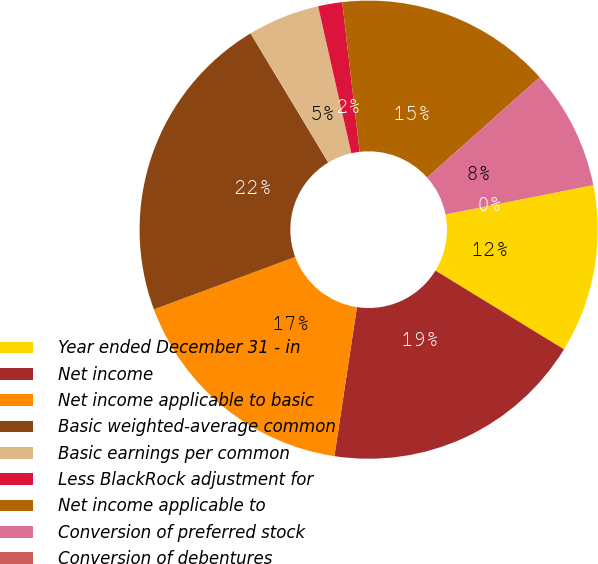Convert chart. <chart><loc_0><loc_0><loc_500><loc_500><pie_chart><fcel>Year ended December 31 - in<fcel>Net income<fcel>Net income applicable to basic<fcel>Basic weighted-average common<fcel>Basic earnings per common<fcel>Less BlackRock adjustment for<fcel>Net income applicable to<fcel>Conversion of preferred stock<fcel>Conversion of debentures<nl><fcel>11.86%<fcel>18.64%<fcel>16.95%<fcel>22.03%<fcel>5.08%<fcel>1.7%<fcel>15.25%<fcel>8.47%<fcel>0.0%<nl></chart> 